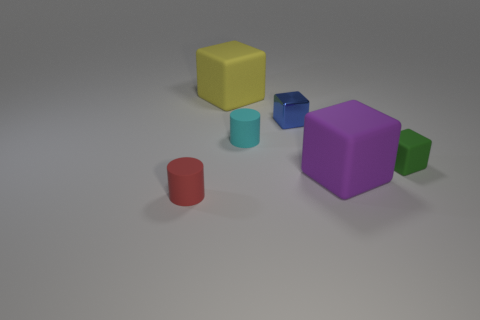Is there any other thing that has the same material as the tiny blue block?
Make the answer very short. No. What number of things are brown shiny objects or small matte things that are to the right of the big yellow matte object?
Your answer should be very brief. 2. There is a matte block in front of the small green thing; what size is it?
Provide a short and direct response. Large. Is the purple cube made of the same material as the tiny blue cube right of the tiny cyan cylinder?
Provide a succinct answer. No. There is a big matte thing to the left of the cylinder that is behind the red matte cylinder; what number of big things are right of it?
Offer a terse response. 1. How many red things are either cylinders or cubes?
Provide a succinct answer. 1. What shape is the big object in front of the yellow thing?
Provide a short and direct response. Cube. What is the color of the rubber block that is the same size as the red cylinder?
Provide a short and direct response. Green. There is a cyan object; does it have the same shape as the tiny matte thing in front of the purple block?
Your answer should be compact. Yes. There is a green object right of the big matte thing that is to the left of the big purple rubber object that is behind the tiny red matte cylinder; what is it made of?
Offer a very short reply. Rubber. 